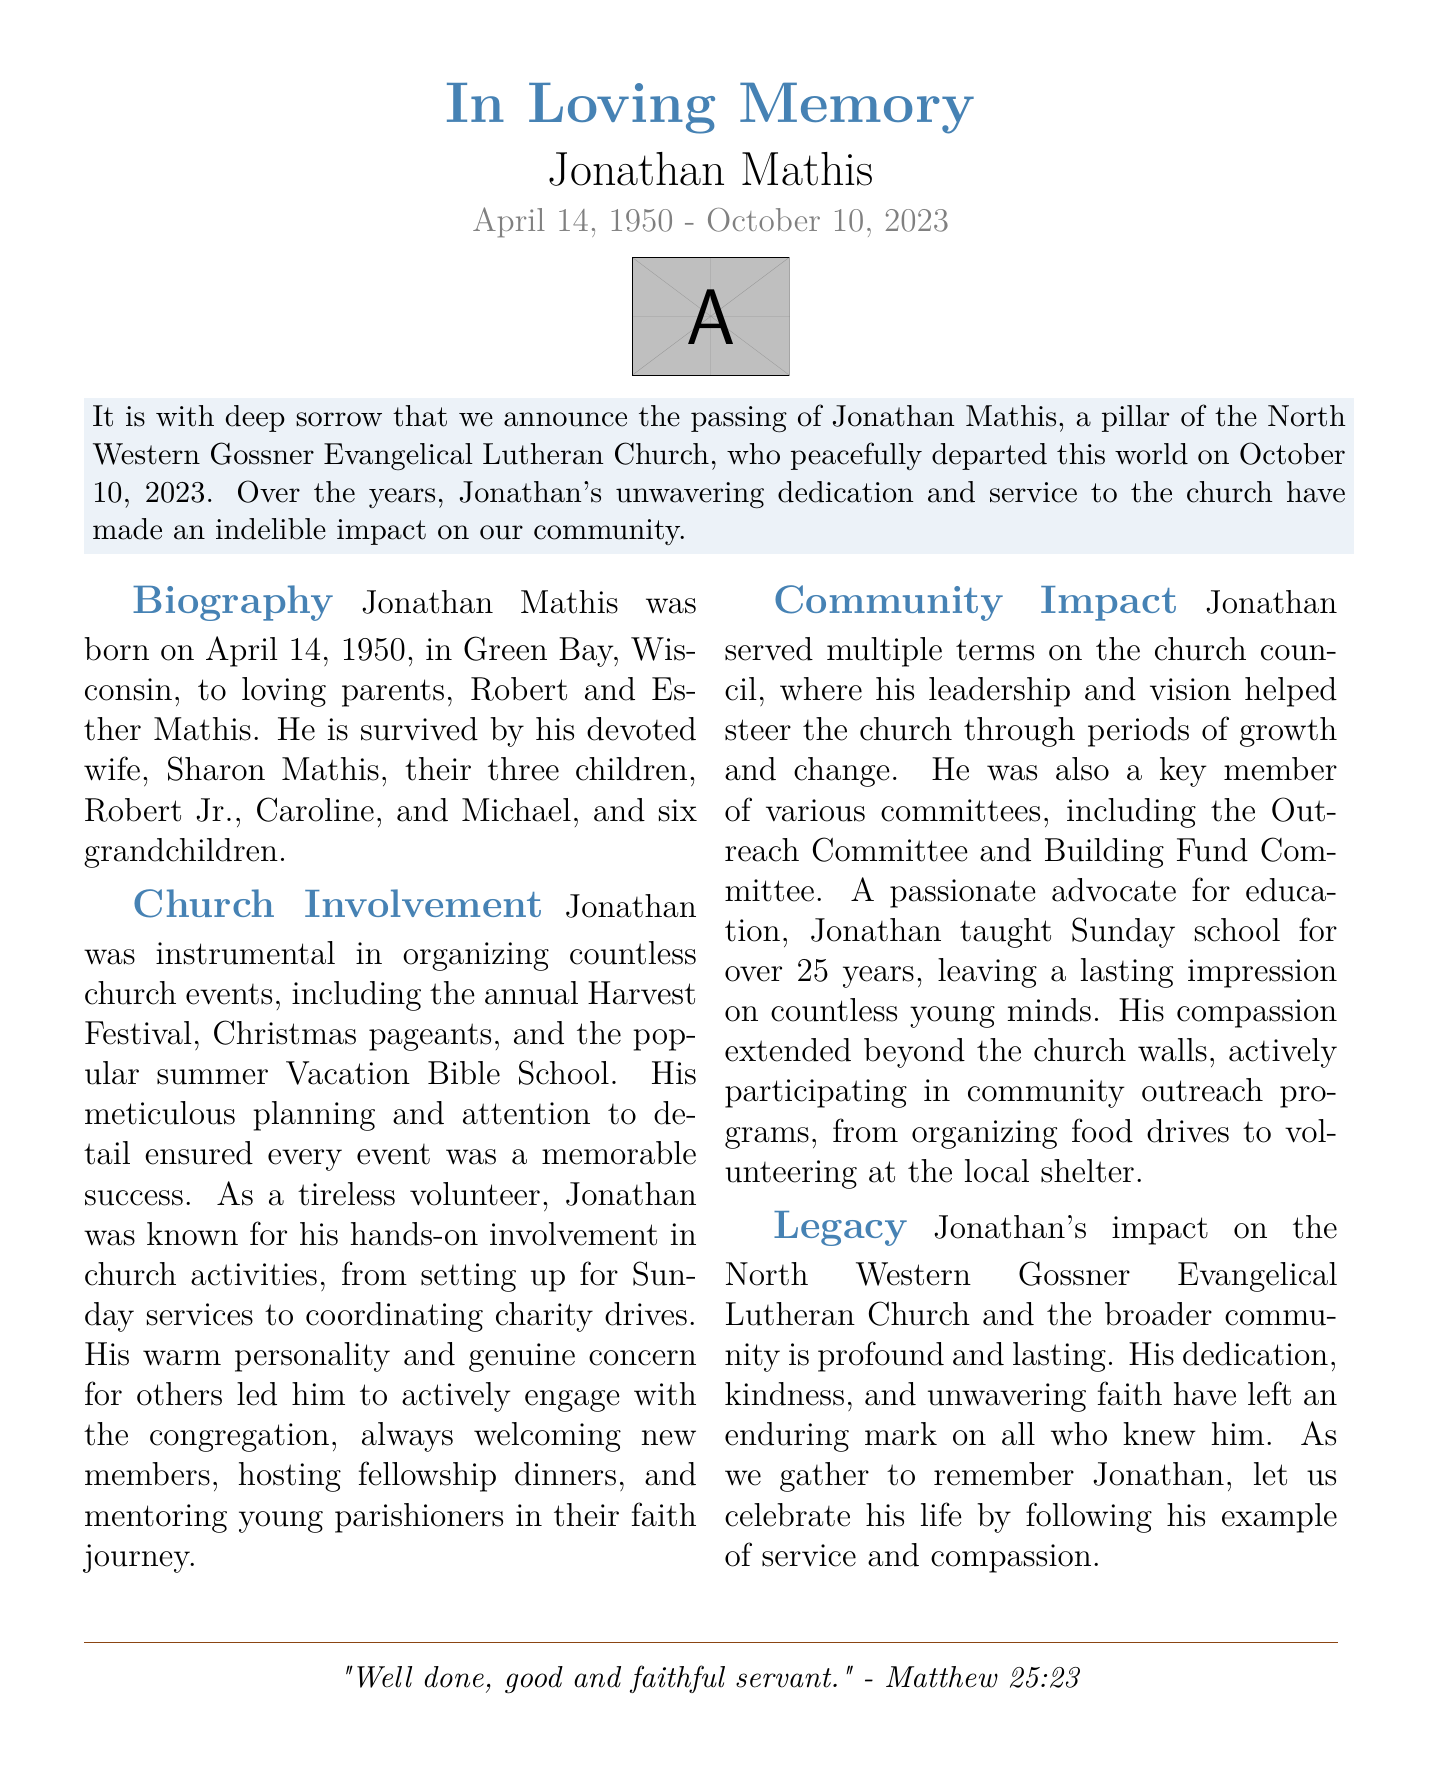What was Jonathan Mathis's date of birth? Jonathan Mathis was born on April 14, 1950, as stated in the biography section.
Answer: April 14, 1950 Who are Jonathan Mathis's children? The document lists Robert Jr., Caroline, and Michael as his children.
Answer: Robert Jr., Caroline, and Michael When did Jonathan Mathis pass away? The obituary mentions that he passed away on October 10, 2023.
Answer: October 10, 2023 What event did Jonathan help organize annually? The document specifically mentions the annual Harvest Festival as one of the events he organized.
Answer: Harvest Festival For how many years did Jonathan teach Sunday school? The document states that he taught Sunday school for over 25 years.
Answer: Over 25 years What was Jonathan's role in the church council? Jonathan served multiple terms on the church council, indicating a leadership role as per the church involvement section.
Answer: Leadership What kind of personality did Jonathan exhibit towards new members? The document describes his warm personality and genuine concern for others when interacting with new members.
Answer: Warm personality What biblical quote is included in the obituary? The document includes a quote from Matthew 25:23 as a biblical reference at the end.
Answer: "Well done, good and faithful servant." How many grandchildren did Jonathan Mathis have? The document states that he is survived by six grandchildren.
Answer: Six What committees did Jonathan serve on? The document mentions his membership in the Outreach Committee and Building Fund Committee.
Answer: Outreach Committee and Building Fund Committee 